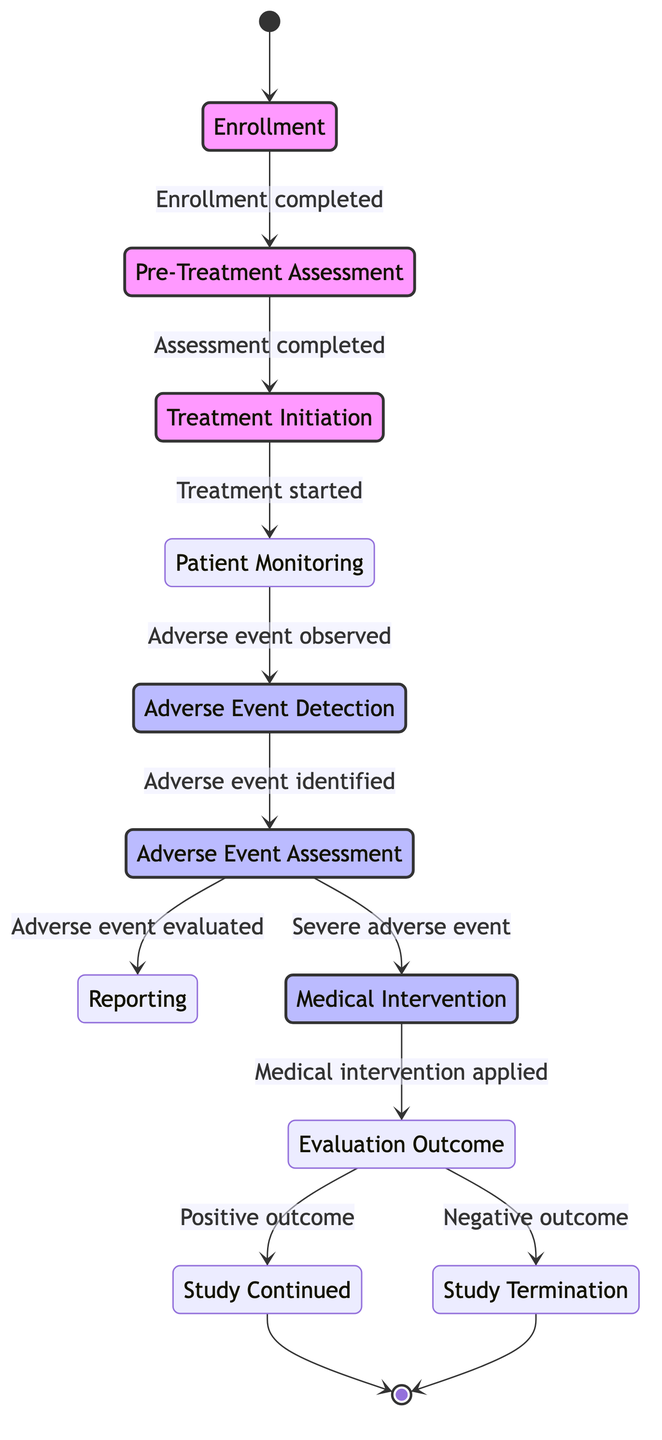What is the first state in the diagram? The diagram starts with the initial state, which is labeled as "Enrollment." This state signifies the beginning of the patient's journey in the clinical trial process.
Answer: Enrollment How many states are present in the diagram? By counting the distinct states listed in the diagram, we can identify a total of 10 states involved in the adverse event handling process in multi-center clinical trials.
Answer: 10 What triggers the transition from Patient Monitoring to Adverse Event Detection? The transition from "Patient Monitoring" to "Adverse Event Detection" is triggered by the observation of an adverse event during the continuous health monitoring of the patient.
Answer: Adverse event observed What is the outcome if the Evaluation Outcome is negative? If the evaluation outcome is negative, the next step according to the diagram is to transition to "Study Termination," indicating that the study cannot continue due to adverse findings.
Answer: Study Termination Which state requires the evaluation of an adverse event? The state that specifically focuses on assessing the adverse event is "Adverse Event Assessment." This state involves evaluating the severity and its relationship to the study medication.
Answer: Adverse Event Assessment What happens immediately after an adverse event is identified? Once an adverse event is identified in the "Adverse Event Detection" state, it transitions to "Adverse Event Assessment" to determine the severity and relationship of the event to the treatment.
Answer: Adverse Event Assessment Which state follows if a medical intervention is applied successfully? If the medical intervention applied is successful, it leads to the "Evaluation Outcome" state where the results of the intervention are assessed. If the outcome is positive, the study continues.
Answer: Evaluation Outcome What is the relationship between Medical Intervention and Reporting? The "Medical Intervention" state can occur independently of the "Reporting" state since it follows its own transition directly from "Adverse Event Assessment" when there is a severe adverse event.
Answer: No direct relationship What occurs after reporting an adverse event? After reporting the adverse event in the "Reporting" state, the clinical trial team typically would return to monitoring the patient's condition or could lead to further medical interventions based on the assessment.
Answer: Patient Monitoring What step indicates the completion of patient enrollment? The completion of patient enrollment is marked by the transition labeled as "Enrollment completed," which allows the patient to move to the next state of "Pre-Treatment Assessment."
Answer: Enrollment completed 